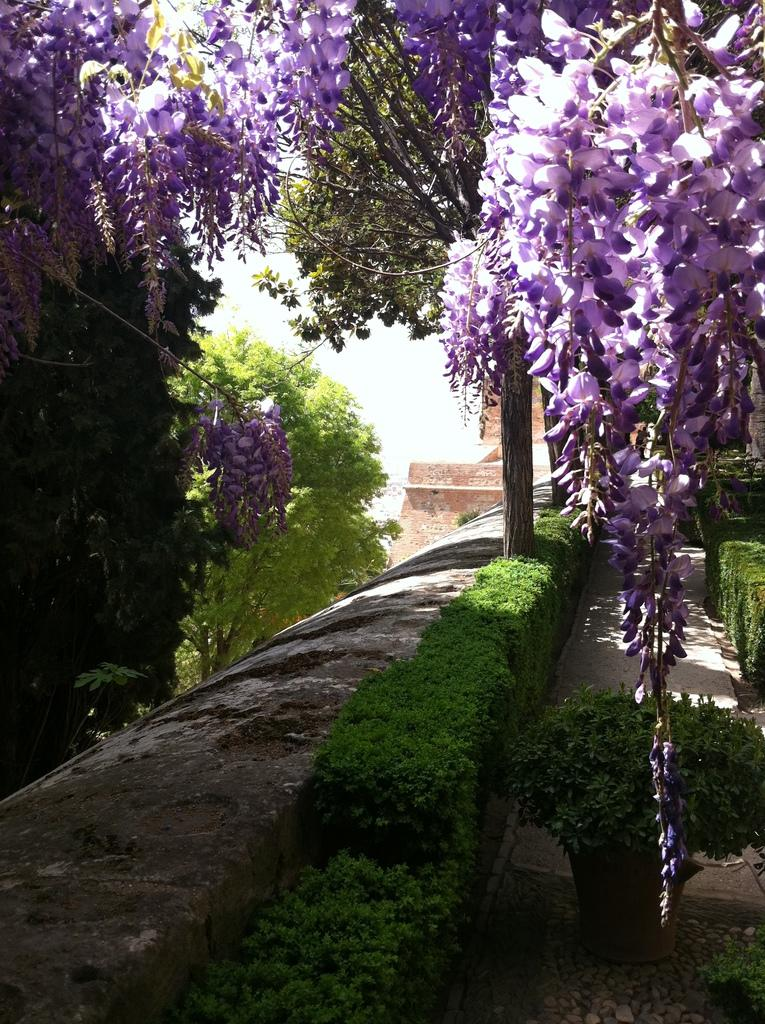What type of living organisms can be seen in the image? Plants can be seen in the image. Are there any specific features of the plants that are visible? Yes, there are flowers visible at the top of the image. Reasoning: Let's think step by step to produce the conversation. We start by mentioning the main subject of the image, which is the plants. Then, we focus on the specific features of the plants, which are the flowers visible at the top of the image. We ensure that each question can be answered definitively with the information given and avoid yes/no questions. Absurd Question/Answer: What type of stone is being used for teaching in the image? There is no stone or teaching activity present in the image; it features plants with flowers. What appliance can be seen operating in the image? There are no appliances visible in the image; it only contains plants and flowers. 